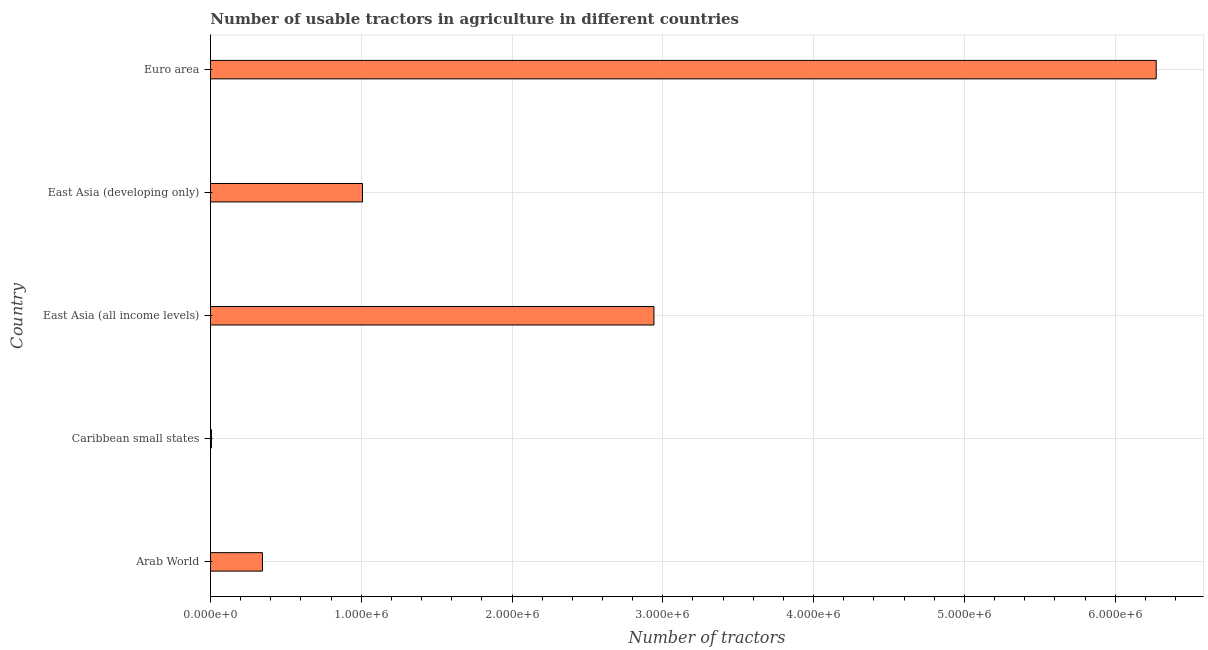Does the graph contain any zero values?
Give a very brief answer. No. What is the title of the graph?
Make the answer very short. Number of usable tractors in agriculture in different countries. What is the label or title of the X-axis?
Your answer should be very brief. Number of tractors. What is the label or title of the Y-axis?
Your response must be concise. Country. What is the number of tractors in East Asia (developing only)?
Make the answer very short. 1.01e+06. Across all countries, what is the maximum number of tractors?
Provide a succinct answer. 6.27e+06. Across all countries, what is the minimum number of tractors?
Give a very brief answer. 6417. In which country was the number of tractors maximum?
Your answer should be very brief. Euro area. In which country was the number of tractors minimum?
Make the answer very short. Caribbean small states. What is the sum of the number of tractors?
Provide a short and direct response. 1.06e+07. What is the difference between the number of tractors in Caribbean small states and Euro area?
Ensure brevity in your answer.  -6.27e+06. What is the average number of tractors per country?
Offer a terse response. 2.11e+06. What is the median number of tractors?
Ensure brevity in your answer.  1.01e+06. What is the ratio of the number of tractors in Caribbean small states to that in Euro area?
Keep it short and to the point. 0. What is the difference between the highest and the second highest number of tractors?
Your answer should be very brief. 3.33e+06. Is the sum of the number of tractors in Arab World and Euro area greater than the maximum number of tractors across all countries?
Ensure brevity in your answer.  Yes. What is the difference between the highest and the lowest number of tractors?
Offer a terse response. 6.27e+06. In how many countries, is the number of tractors greater than the average number of tractors taken over all countries?
Give a very brief answer. 2. Are all the bars in the graph horizontal?
Ensure brevity in your answer.  Yes. How many countries are there in the graph?
Offer a terse response. 5. What is the difference between two consecutive major ticks on the X-axis?
Provide a short and direct response. 1.00e+06. What is the Number of tractors of Arab World?
Offer a terse response. 3.45e+05. What is the Number of tractors in Caribbean small states?
Your answer should be compact. 6417. What is the Number of tractors of East Asia (all income levels)?
Your answer should be very brief. 2.94e+06. What is the Number of tractors of East Asia (developing only)?
Provide a succinct answer. 1.01e+06. What is the Number of tractors in Euro area?
Your response must be concise. 6.27e+06. What is the difference between the Number of tractors in Arab World and Caribbean small states?
Make the answer very short. 3.38e+05. What is the difference between the Number of tractors in Arab World and East Asia (all income levels)?
Make the answer very short. -2.60e+06. What is the difference between the Number of tractors in Arab World and East Asia (developing only)?
Ensure brevity in your answer.  -6.64e+05. What is the difference between the Number of tractors in Arab World and Euro area?
Provide a succinct answer. -5.93e+06. What is the difference between the Number of tractors in Caribbean small states and East Asia (all income levels)?
Offer a very short reply. -2.93e+06. What is the difference between the Number of tractors in Caribbean small states and East Asia (developing only)?
Offer a terse response. -1.00e+06. What is the difference between the Number of tractors in Caribbean small states and Euro area?
Ensure brevity in your answer.  -6.27e+06. What is the difference between the Number of tractors in East Asia (all income levels) and East Asia (developing only)?
Provide a short and direct response. 1.93e+06. What is the difference between the Number of tractors in East Asia (all income levels) and Euro area?
Keep it short and to the point. -3.33e+06. What is the difference between the Number of tractors in East Asia (developing only) and Euro area?
Offer a very short reply. -5.26e+06. What is the ratio of the Number of tractors in Arab World to that in Caribbean small states?
Offer a terse response. 53.72. What is the ratio of the Number of tractors in Arab World to that in East Asia (all income levels)?
Offer a very short reply. 0.12. What is the ratio of the Number of tractors in Arab World to that in East Asia (developing only)?
Provide a succinct answer. 0.34. What is the ratio of the Number of tractors in Arab World to that in Euro area?
Provide a succinct answer. 0.06. What is the ratio of the Number of tractors in Caribbean small states to that in East Asia (all income levels)?
Your response must be concise. 0. What is the ratio of the Number of tractors in Caribbean small states to that in East Asia (developing only)?
Keep it short and to the point. 0.01. What is the ratio of the Number of tractors in Caribbean small states to that in Euro area?
Your response must be concise. 0. What is the ratio of the Number of tractors in East Asia (all income levels) to that in East Asia (developing only)?
Your response must be concise. 2.92. What is the ratio of the Number of tractors in East Asia (all income levels) to that in Euro area?
Keep it short and to the point. 0.47. What is the ratio of the Number of tractors in East Asia (developing only) to that in Euro area?
Keep it short and to the point. 0.16. 